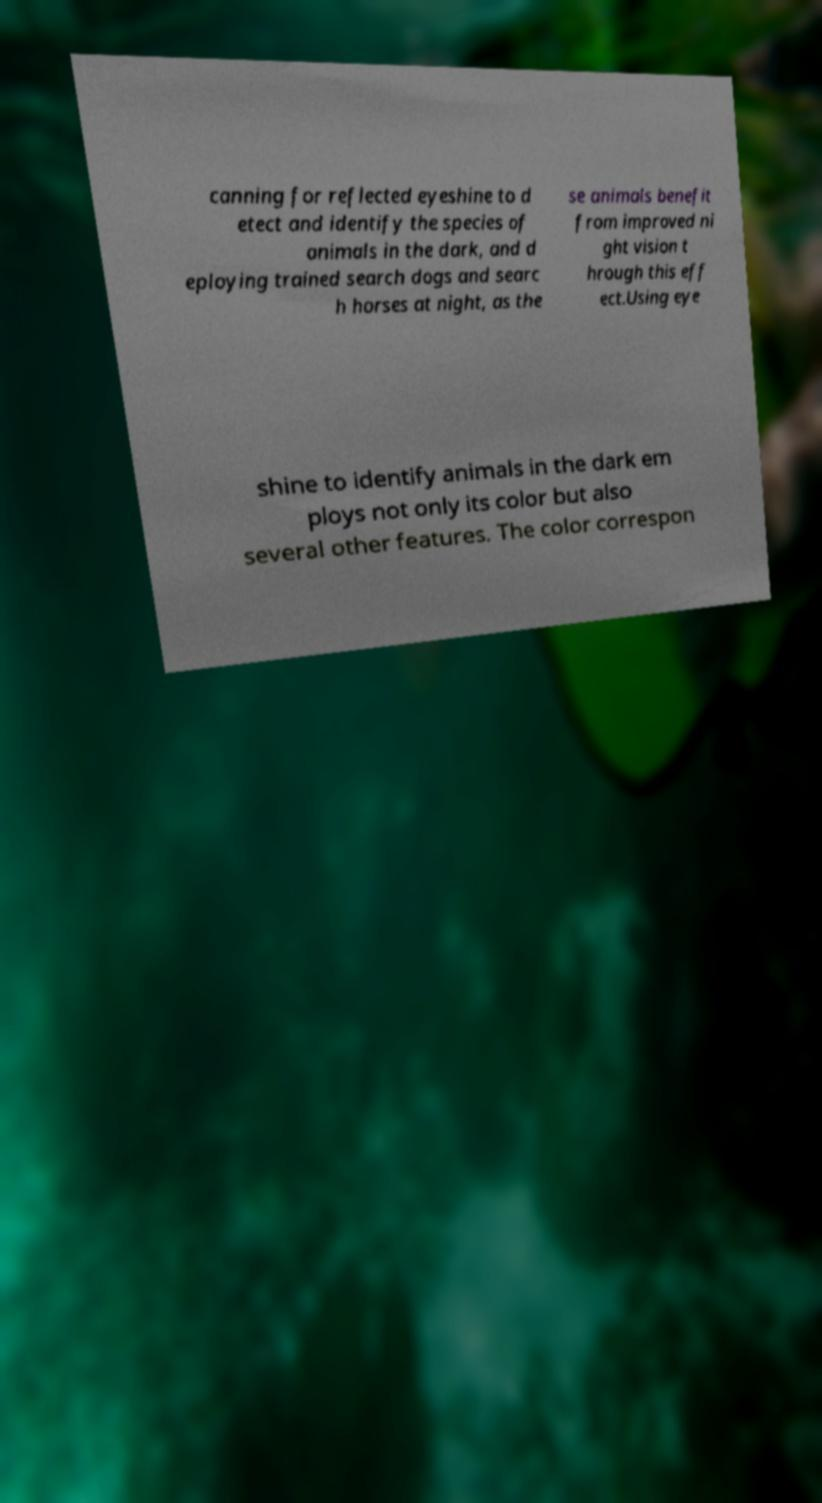Can you read and provide the text displayed in the image?This photo seems to have some interesting text. Can you extract and type it out for me? canning for reflected eyeshine to d etect and identify the species of animals in the dark, and d eploying trained search dogs and searc h horses at night, as the se animals benefit from improved ni ght vision t hrough this eff ect.Using eye shine to identify animals in the dark em ploys not only its color but also several other features. The color correspon 